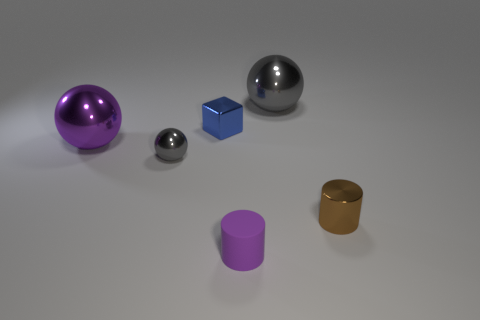Add 1 brown cylinders. How many objects exist? 7 Subtract all cubes. How many objects are left? 5 Subtract 0 blue balls. How many objects are left? 6 Subtract all tiny brown cylinders. Subtract all tiny metallic cylinders. How many objects are left? 4 Add 1 tiny brown objects. How many tiny brown objects are left? 2 Add 1 blue blocks. How many blue blocks exist? 2 